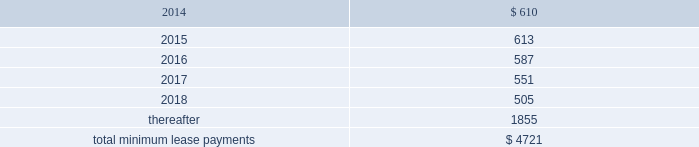Table of contents rent expense under all operating leases , including both cancelable and noncancelable leases , was $ 645 million , $ 488 million and $ 338 million in 2013 , 2012 and 2011 , respectively .
Future minimum lease payments under noncancelable operating leases having remaining terms in excess of one year as of september 28 , 2013 , are as follows ( in millions ) : other commitments as of september 28 , 2013 , the company had outstanding off-balance sheet third-party manufacturing commitments and component purchase commitments of $ 18.6 billion .
In addition to the off-balance sheet commitments mentioned above , the company had outstanding obligations of $ 1.3 billion as of september 28 , 2013 , which consisted mainly of commitments to acquire capital assets , including product tooling and manufacturing process equipment , and commitments related to advertising , research and development , internet and telecommunications services and other obligations .
Contingencies the company is subject to various legal proceedings and claims that have arisen in the ordinary course of business and that have not been fully adjudicated .
In the opinion of management , there was not at least a reasonable possibility the company may have incurred a material loss , or a material loss in excess of a recorded accrual , with respect to loss contingencies .
However , the outcome of litigation is inherently uncertain .
Therefore , although management considers the likelihood of such an outcome to be remote , if one or more of these legal matters were resolved against the company in a reporting period for amounts in excess of management 2019s expectations , the company 2019s consolidated financial statements for that reporting period could be materially adversely affected .
Apple inc .
Samsung electronics co. , ltd , et al .
On august 24 , 2012 , a jury returned a verdict awarding the company $ 1.05 billion in its lawsuit against samsung electronics co. , ltd and affiliated parties in the united states district court , northern district of california , san jose division .
On march 1 , 2013 , the district court upheld $ 599 million of the jury 2019s award and ordered a new trial as to the remainder .
Because the award is subject to entry of final judgment , partial re-trial and appeal , the company has not recognized the award in its results of operations .
Virnetx , inc .
Apple inc .
Et al .
On august 11 , 2010 , virnetx , inc .
Filed an action against the company alleging that certain of its products infringed on four patents relating to network communications technology .
On november 6 , 2012 , a jury returned a verdict against the company , and awarded damages of $ 368 million .
The company is challenging the verdict , believes it has valid defenses and has not recorded a loss accrual at this time. .

Why is the information relative to 2012 costs incorrect and what would the correct information be? 
Rationale: apple has not taken the losses for the virnet.inc lawsuit because it requested a retrial . this means that the lease expensive for that year are incorrect and should be 856 million .
Computations: (488 + 368)
Answer: 856.0. 